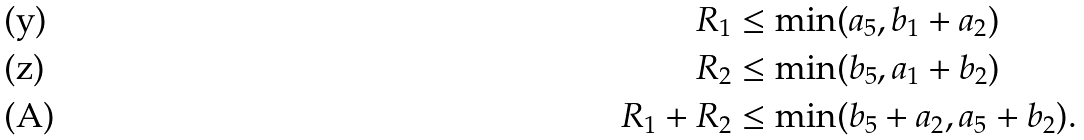<formula> <loc_0><loc_0><loc_500><loc_500>R _ { 1 } & \leq \min ( a _ { 5 } , b _ { 1 } + a _ { 2 } ) \\ R _ { 2 } & \leq \min ( b _ { 5 } , a _ { 1 } + b _ { 2 } ) \\ R _ { 1 } + R _ { 2 } & \leq \min ( b _ { 5 } + a _ { 2 } , a _ { 5 } + b _ { 2 } ) .</formula> 